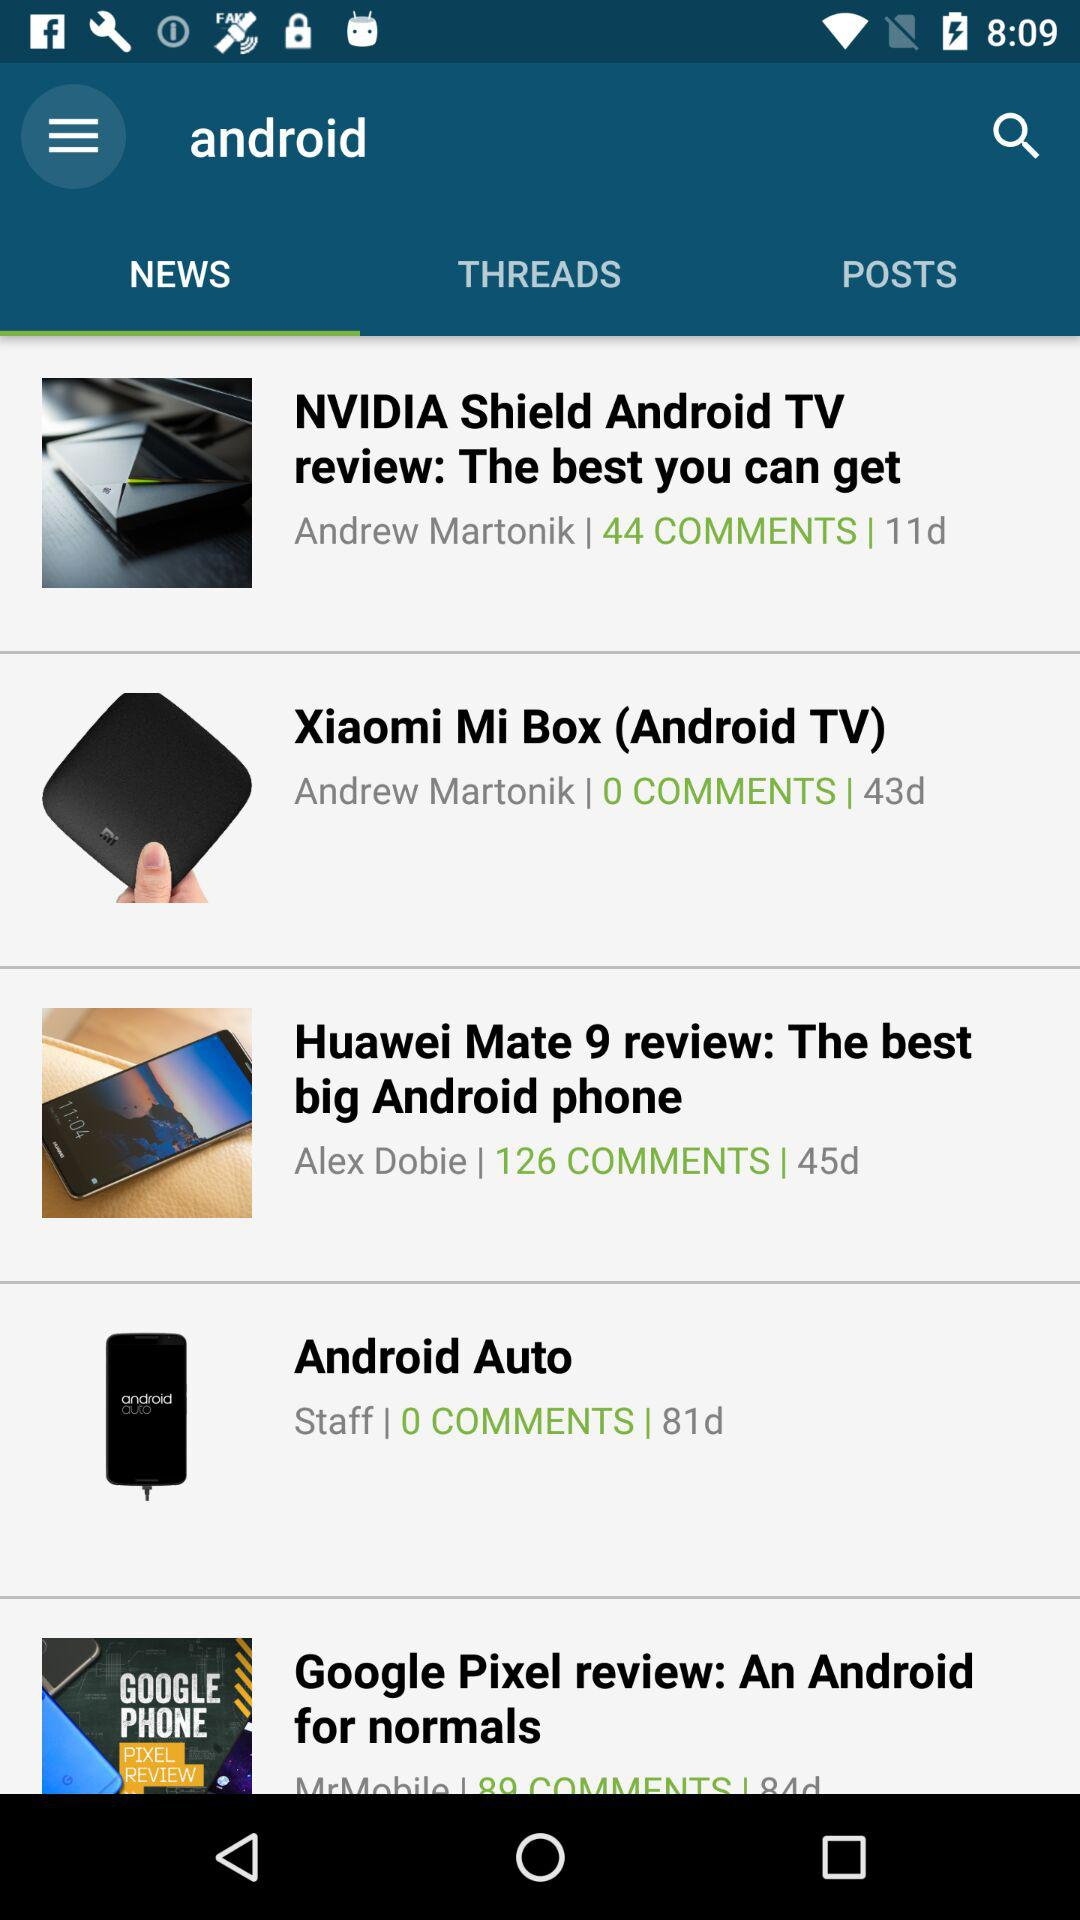When was the most recent post posted?
When the provided information is insufficient, respond with <no answer>. <no answer> 